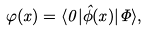<formula> <loc_0><loc_0><loc_500><loc_500>\varphi ( x ) = \langle 0 | \hat { \phi } ( x ) | \Phi \rangle ,</formula> 